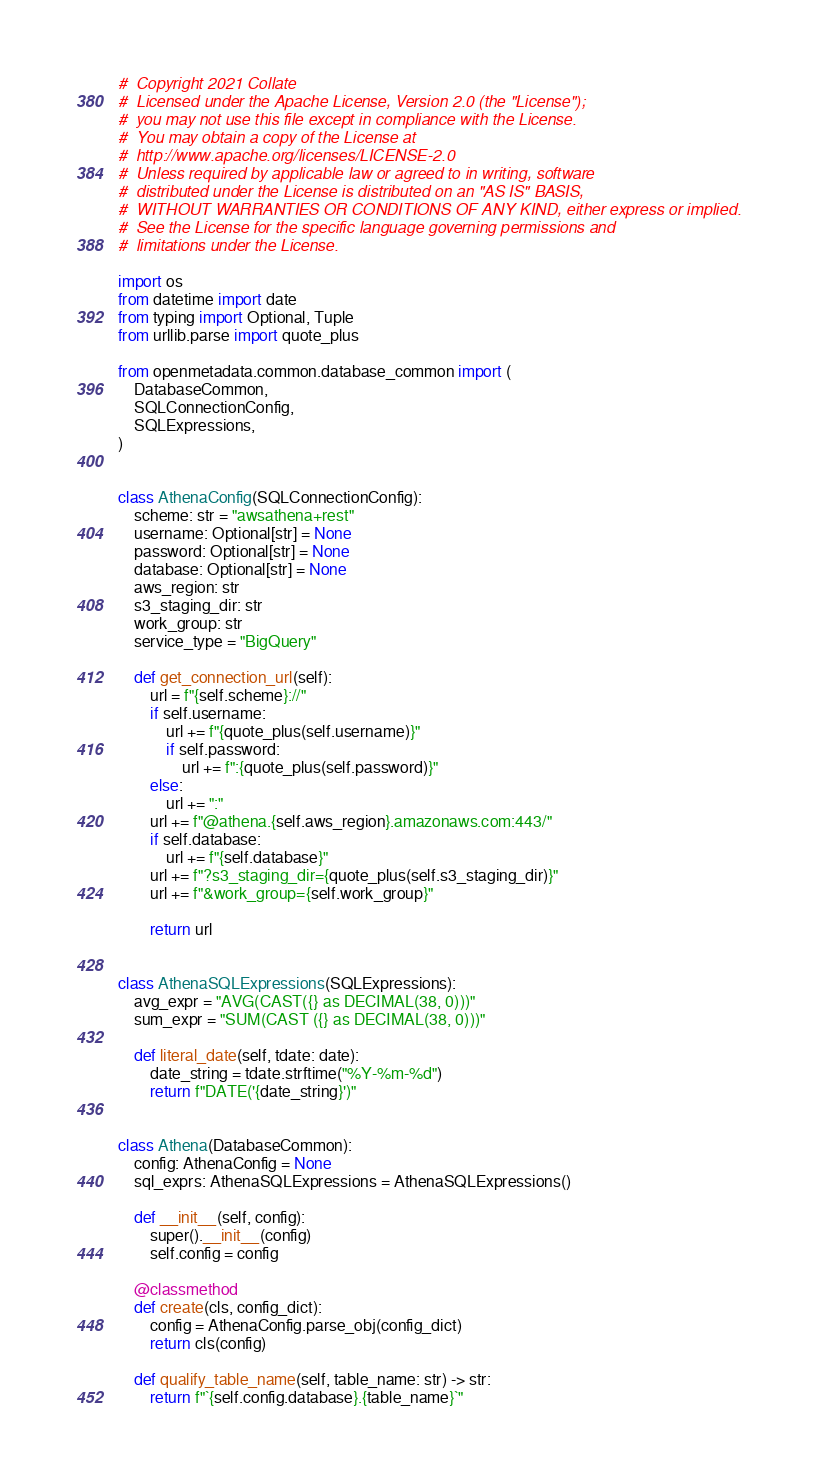<code> <loc_0><loc_0><loc_500><loc_500><_Python_>#  Copyright 2021 Collate
#  Licensed under the Apache License, Version 2.0 (the "License");
#  you may not use this file except in compliance with the License.
#  You may obtain a copy of the License at
#  http://www.apache.org/licenses/LICENSE-2.0
#  Unless required by applicable law or agreed to in writing, software
#  distributed under the License is distributed on an "AS IS" BASIS,
#  WITHOUT WARRANTIES OR CONDITIONS OF ANY KIND, either express or implied.
#  See the License for the specific language governing permissions and
#  limitations under the License.

import os
from datetime import date
from typing import Optional, Tuple
from urllib.parse import quote_plus

from openmetadata.common.database_common import (
    DatabaseCommon,
    SQLConnectionConfig,
    SQLExpressions,
)


class AthenaConfig(SQLConnectionConfig):
    scheme: str = "awsathena+rest"
    username: Optional[str] = None
    password: Optional[str] = None
    database: Optional[str] = None
    aws_region: str
    s3_staging_dir: str
    work_group: str
    service_type = "BigQuery"

    def get_connection_url(self):
        url = f"{self.scheme}://"
        if self.username:
            url += f"{quote_plus(self.username)}"
            if self.password:
                url += f":{quote_plus(self.password)}"
        else:
            url += ":"
        url += f"@athena.{self.aws_region}.amazonaws.com:443/"
        if self.database:
            url += f"{self.database}"
        url += f"?s3_staging_dir={quote_plus(self.s3_staging_dir)}"
        url += f"&work_group={self.work_group}"

        return url


class AthenaSQLExpressions(SQLExpressions):
    avg_expr = "AVG(CAST({} as DECIMAL(38, 0)))"
    sum_expr = "SUM(CAST ({} as DECIMAL(38, 0)))"

    def literal_date(self, tdate: date):
        date_string = tdate.strftime("%Y-%m-%d")
        return f"DATE('{date_string}')"


class Athena(DatabaseCommon):
    config: AthenaConfig = None
    sql_exprs: AthenaSQLExpressions = AthenaSQLExpressions()

    def __init__(self, config):
        super().__init__(config)
        self.config = config

    @classmethod
    def create(cls, config_dict):
        config = AthenaConfig.parse_obj(config_dict)
        return cls(config)

    def qualify_table_name(self, table_name: str) -> str:
        return f"`{self.config.database}.{table_name}`"
</code> 